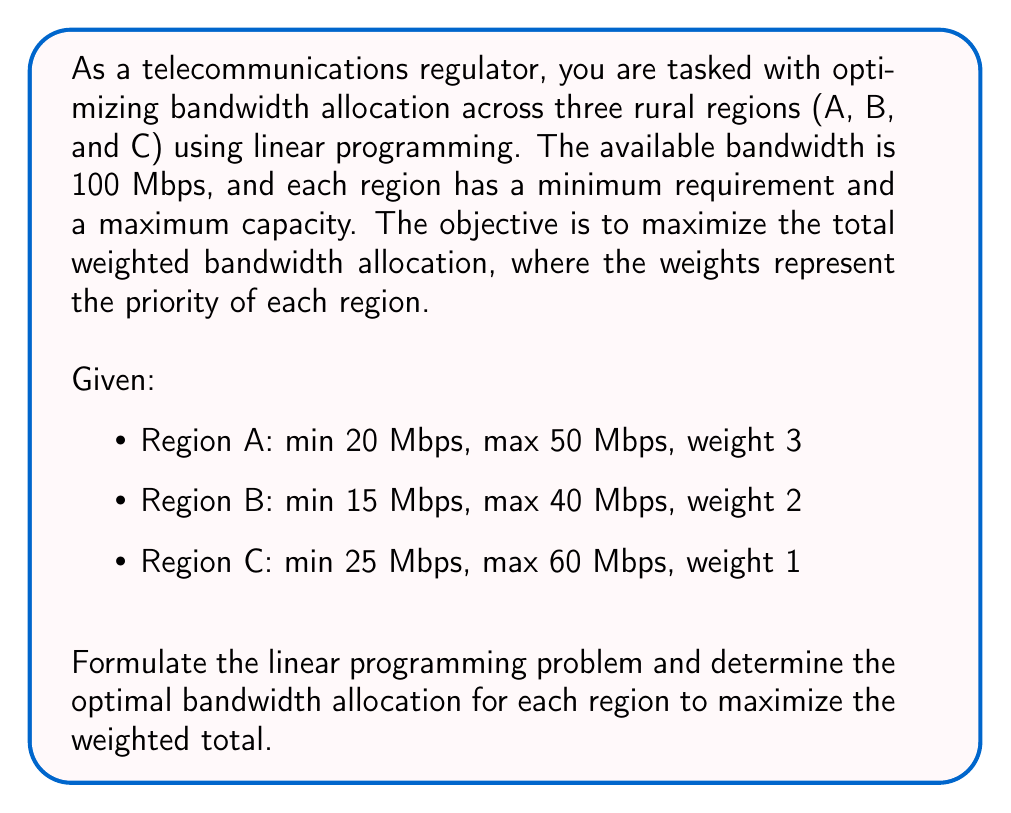Could you help me with this problem? To solve this linear programming problem, we'll follow these steps:

1. Define variables:
   Let $x_A$, $x_B$, and $x_C$ represent the bandwidth allocated to regions A, B, and C, respectively.

2. Formulate the objective function:
   Maximize $Z = 3x_A + 2x_B + x_C$

3. Define constraints:
   a) Minimum requirements:
      $x_A \geq 20$
      $x_B \geq 15$
      $x_C \geq 25$

   b) Maximum capacities:
      $x_A \leq 50$
      $x_B \leq 40$
      $x_C \leq 60$

   c) Total available bandwidth:
      $x_A + x_B + x_C \leq 100$

   d) Non-negativity:
      $x_A, x_B, x_C \geq 0$

4. Solve using the simplex method or a linear programming solver:
   The optimal solution is:
   $x_A = 50$ (at its maximum)
   $x_B = 25$
   $x_C = 25$ (at its minimum)

5. Verify the solution:
   - Total bandwidth used: $50 + 25 + 25 = 100$ Mbps (meets the total available bandwidth constraint)
   - All minimum requirements and maximum capacities are satisfied
   - Objective function value: $Z = 3(50) + 2(25) + 1(25) = 225$

This allocation maximizes the weighted total while satisfying all constraints.
Answer: Region A: 50 Mbps, Region B: 25 Mbps, Region C: 25 Mbps 